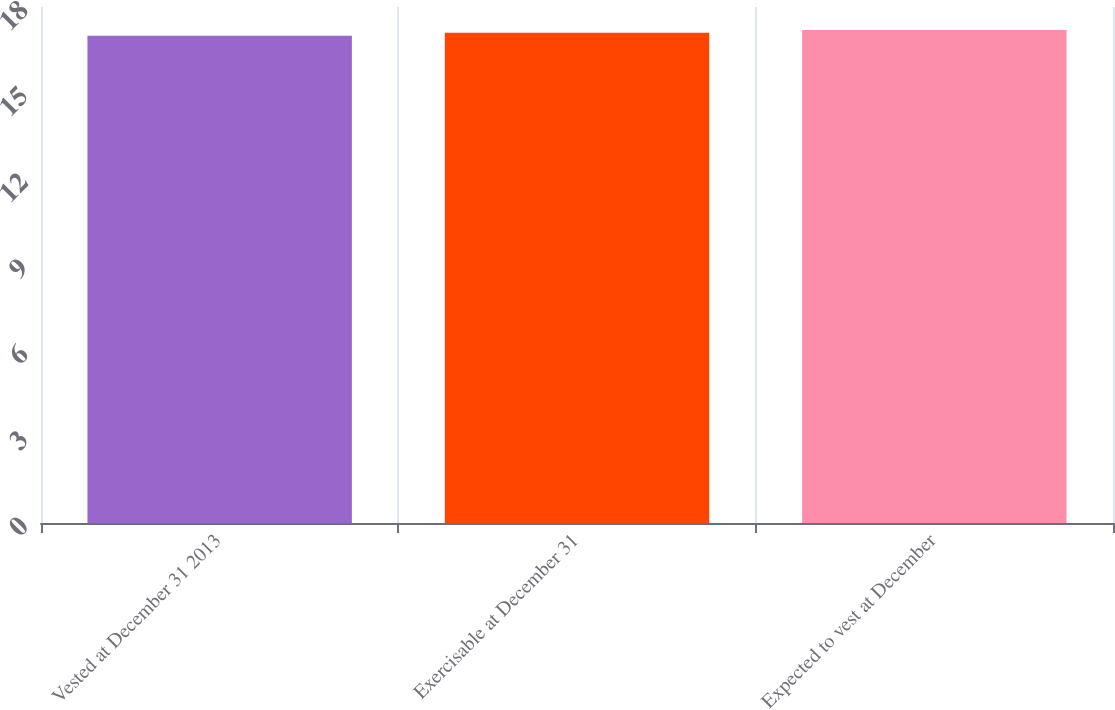Convert chart. <chart><loc_0><loc_0><loc_500><loc_500><bar_chart><fcel>Vested at December 31 2013<fcel>Exercisable at December 31<fcel>Expected to vest at December<nl><fcel>17<fcel>17.1<fcel>17.2<nl></chart> 